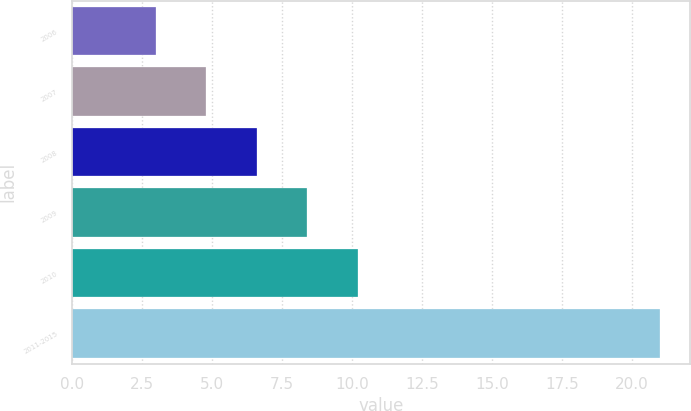<chart> <loc_0><loc_0><loc_500><loc_500><bar_chart><fcel>2006<fcel>2007<fcel>2008<fcel>2009<fcel>2010<fcel>2011-2015<nl><fcel>3<fcel>4.8<fcel>6.6<fcel>8.4<fcel>10.2<fcel>21<nl></chart> 